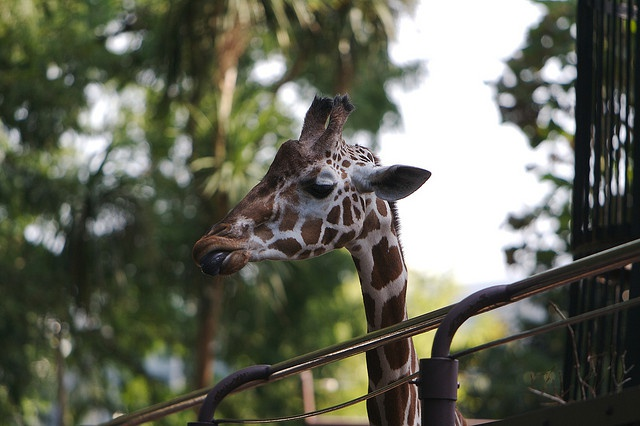Describe the objects in this image and their specific colors. I can see a giraffe in olive, black, gray, and darkgray tones in this image. 